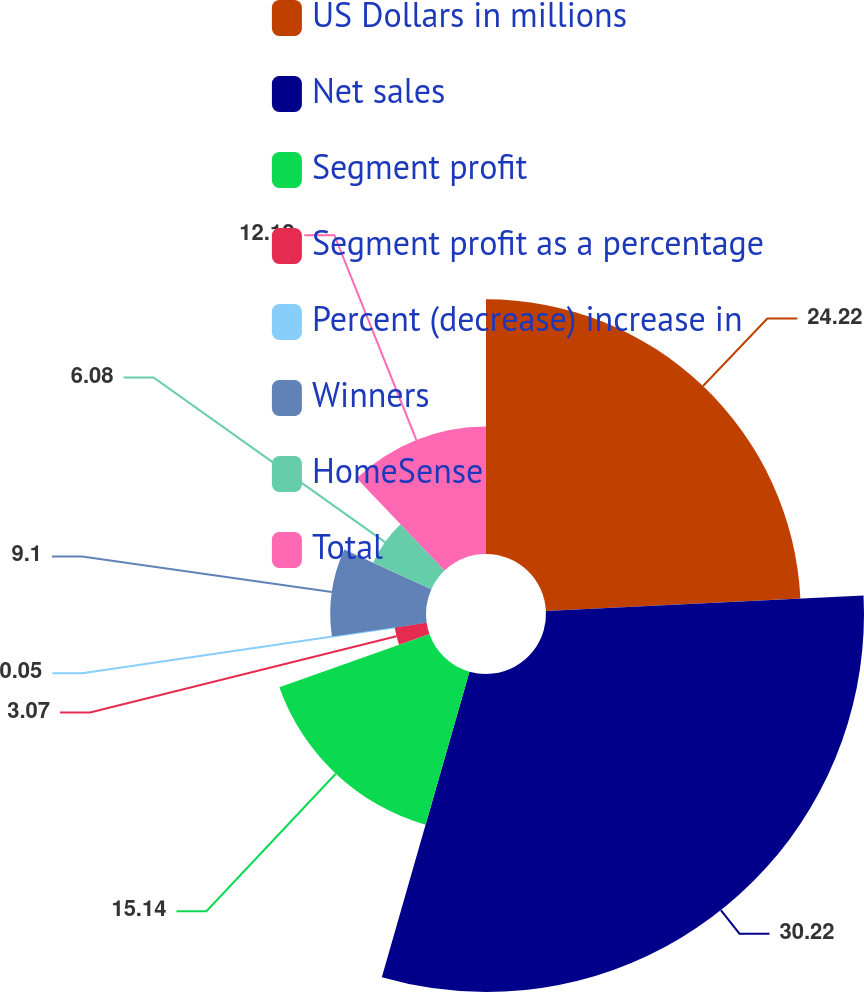Convert chart to OTSL. <chart><loc_0><loc_0><loc_500><loc_500><pie_chart><fcel>US Dollars in millions<fcel>Net sales<fcel>Segment profit<fcel>Segment profit as a percentage<fcel>Percent (decrease) increase in<fcel>Winners<fcel>HomeSense<fcel>Total<nl><fcel>24.22%<fcel>30.23%<fcel>15.14%<fcel>3.07%<fcel>0.05%<fcel>9.1%<fcel>6.08%<fcel>12.12%<nl></chart> 